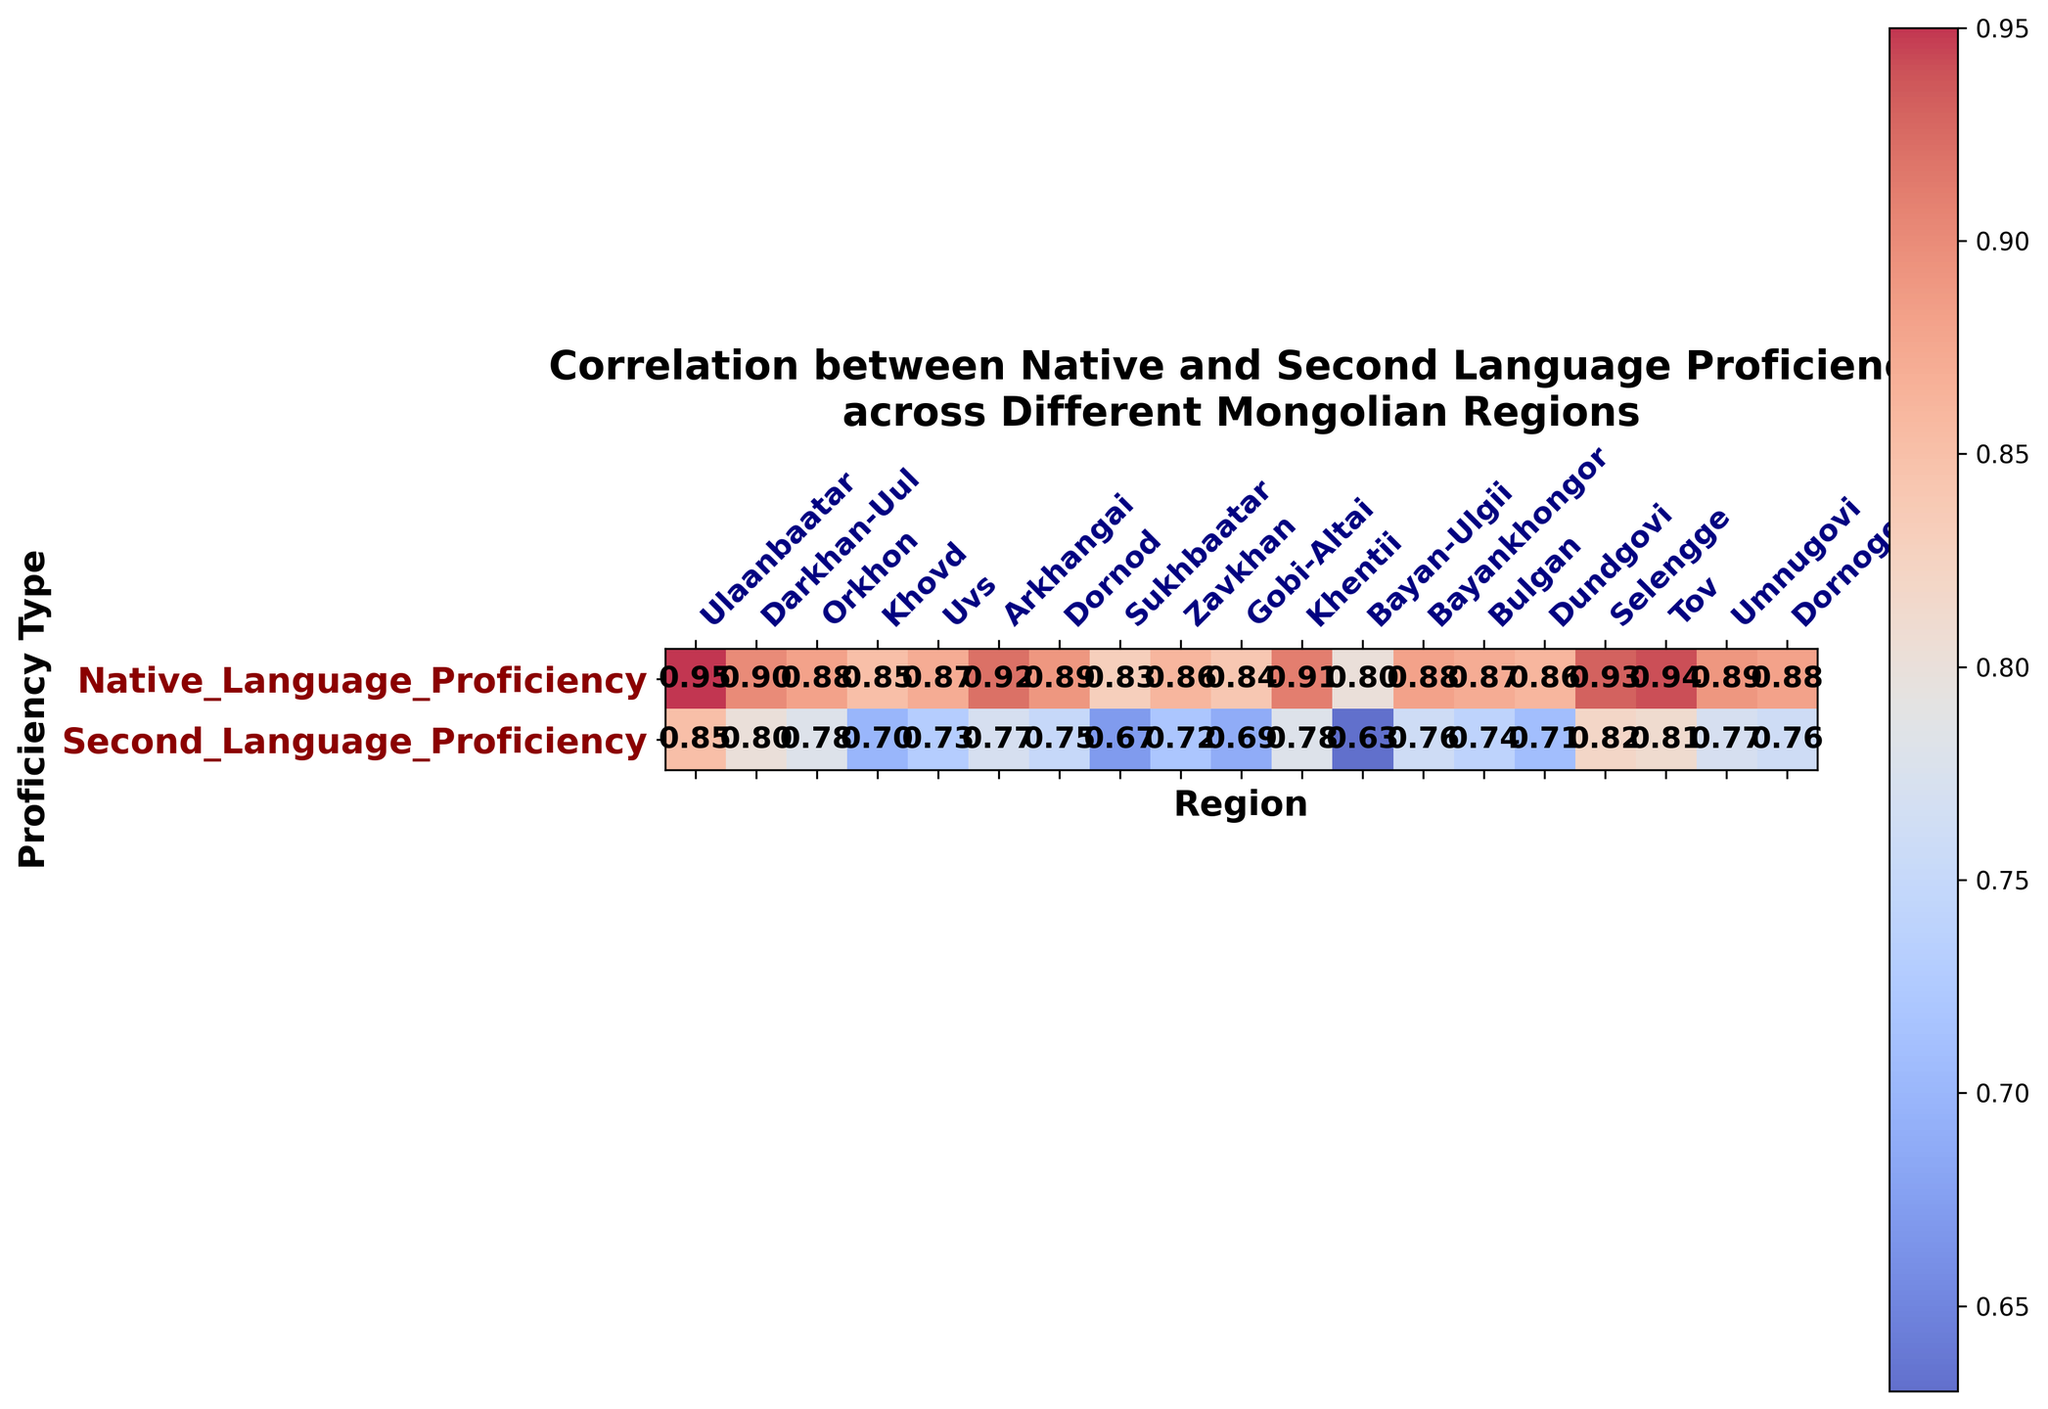what is the highest native language proficiency value and in which region is it found? The highest native language proficiency value can be found by looking at the values in the column for native language proficiency. The highest value is 0.95, and it is in Ulaanbaatar.
Answer: 0.95 in Ulaanbaatar Which region has the lowest second language proficiency value and what is it? To find this, inspect the second language proficiency column in the heatmap. The lowest value is 0.63, found in Bayan-Ulgii.
Answer: 0.63 in Bayan-Ulgii Is there a region where the native and second language proficiencies are equal? By examining both columns, you can see that in none of the regions are the native and second language proficiencies equal.
Answer: No What is the average second language proficiency across all regions? Sum up all the second language proficiency values and divide by the number of regions: (0.85 + 0.80 + 0.78 + 0.70 + 0.73 + 0.77 + 0.75 + 0.67 + 0.72 + 0.69 + 0.78 + 0.63 + 0.76 + 0.74 + 0.71 + 0.82 + 0.81 + 0.77 + 0.76) / 19 = 0.75
Answer: 0.75 Which region has the largest difference between native language proficiency and second language proficiency? Calculate the differences between native and second language proficiencies for each region and find the largest one. The largest difference is 0.80 - 0.63 = 0.17 in Bayan-Ulgii.
Answer: Bayan-Ulgii with a difference of 0.17 In which region is the second language proficiency closest to the average second language proficiency? The average second language proficiency is 0.75. By examining the heatmap, the closest value to 0.75 is 0.74 in Bulgan.
Answer: Bulgan Which regions have a native language proficiency greater than 0.90? Look at the heatmap and list regions with values greater than 0.90 in native language proficiency: Ulaanbaatar, Arkhangai, Khentii, Selengge, and Tov.
Answer: Ulaanbaatar, Arkhangai, Khentii, Selengge, Tov Is there a correlation between high native language proficiency and high second language proficiency across the regions? A positive correlation implies that regions with higher native language proficiency tend to have higher second language proficiency as well. This seems evident in the heatmap as regions such as Ulaanbaatar, where native proficiency is high, also have relatively high second language proficiency.
Answer: Yes What are the native and second language proficiency values for Darkhan-Uul? Refer to the heatmap under Darkhan-Uul for both proficiencies. The native language proficiency is 0.90 and second language proficiency is 0.80.
Answer: 0.90 (native), 0.80 (second) Which region has the most balanced proficiency values (i.e., the smallest difference between native and second language proficiency)? Calculate the differences for each region and identify the smallest. For instance, Selengge has a difference of 0.93 - 0.82 = 0.11, which is the smallest.
Answer: Selengge 